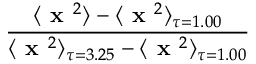Convert formula to latex. <formula><loc_0><loc_0><loc_500><loc_500>\frac { \langle x ^ { 2 } \rangle - \langle x ^ { 2 } \rangle _ { \tau = 1 . 0 0 } } { \langle x ^ { 2 } \rangle _ { \tau = 3 . 2 5 } - \langle x ^ { 2 } \rangle _ { \tau = 1 . 0 0 } }</formula> 